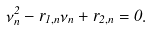Convert formula to latex. <formula><loc_0><loc_0><loc_500><loc_500>\nu _ { n } ^ { 2 } - { r _ { 1 , n } } { \nu _ { n } } + { r _ { 2 , n } } = 0 .</formula> 